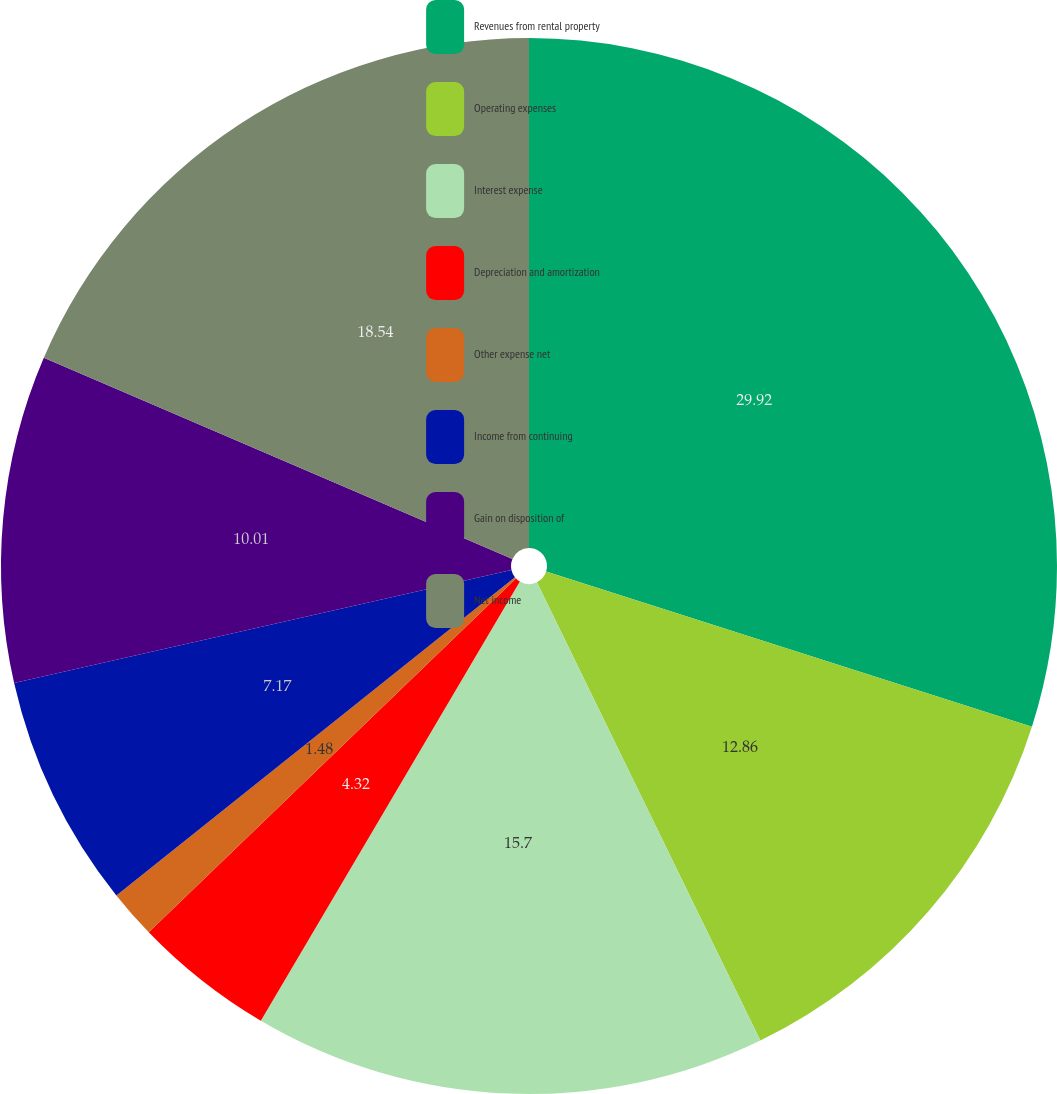Convert chart to OTSL. <chart><loc_0><loc_0><loc_500><loc_500><pie_chart><fcel>Revenues from rental property<fcel>Operating expenses<fcel>Interest expense<fcel>Depreciation and amortization<fcel>Other expense net<fcel>Income from continuing<fcel>Gain on disposition of<fcel>Net income<nl><fcel>29.93%<fcel>12.86%<fcel>15.7%<fcel>4.32%<fcel>1.48%<fcel>7.17%<fcel>10.01%<fcel>18.55%<nl></chart> 